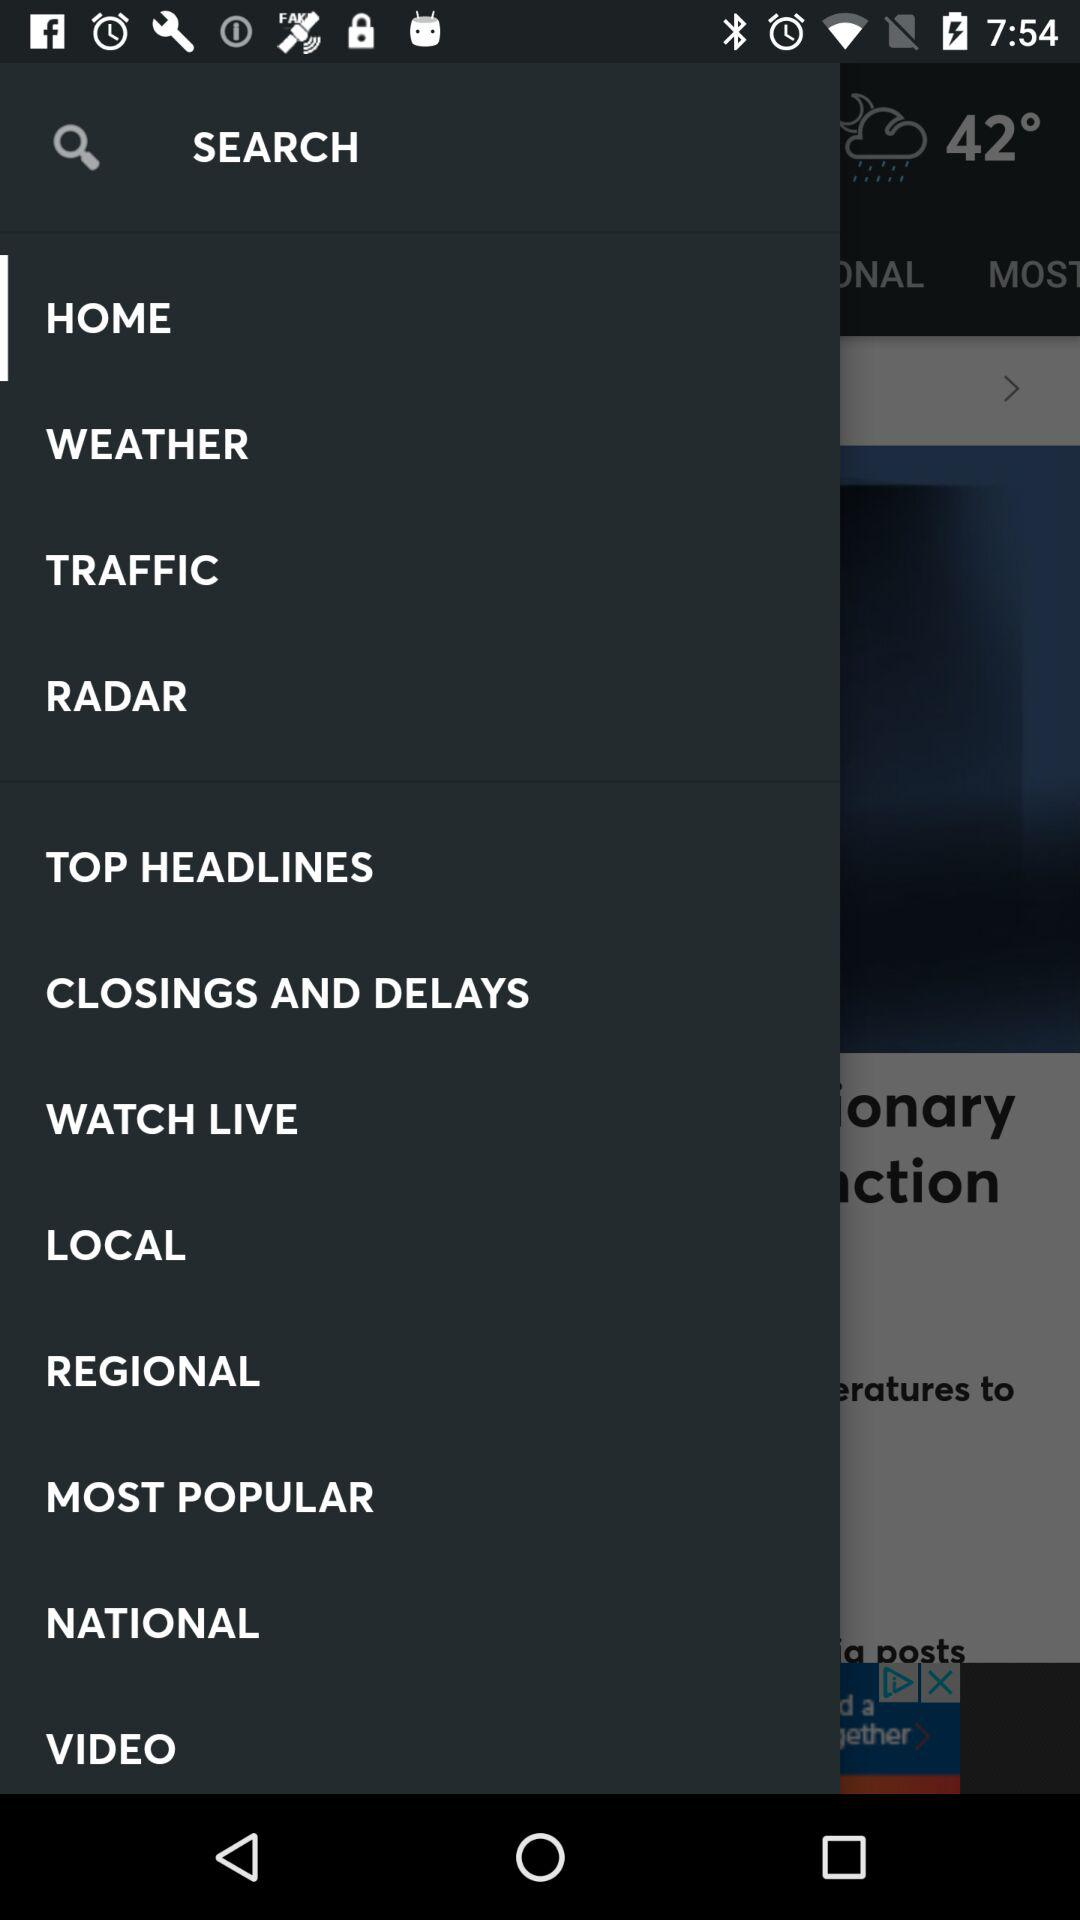How many degrees is the weather?
Answer the question using a single word or phrase. 42° 